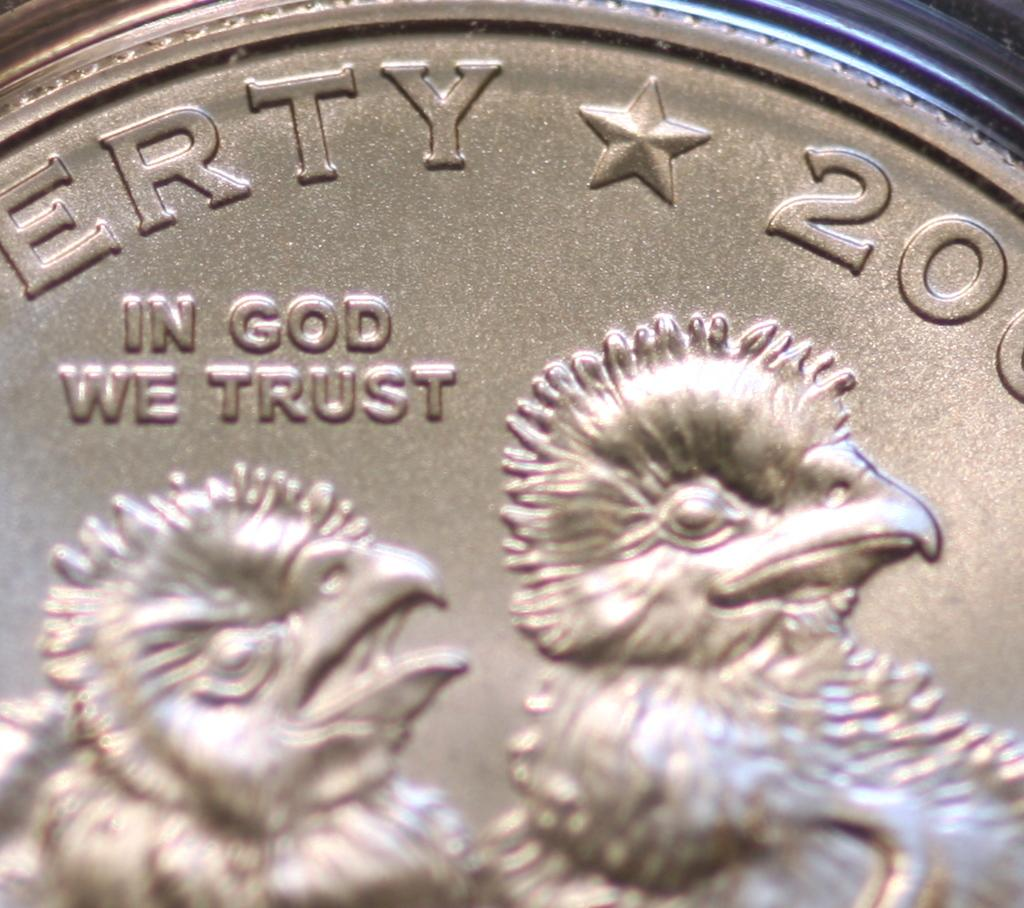<image>
Offer a succinct explanation of the picture presented. A coin featuring two baby birds says "In God We Trust". 